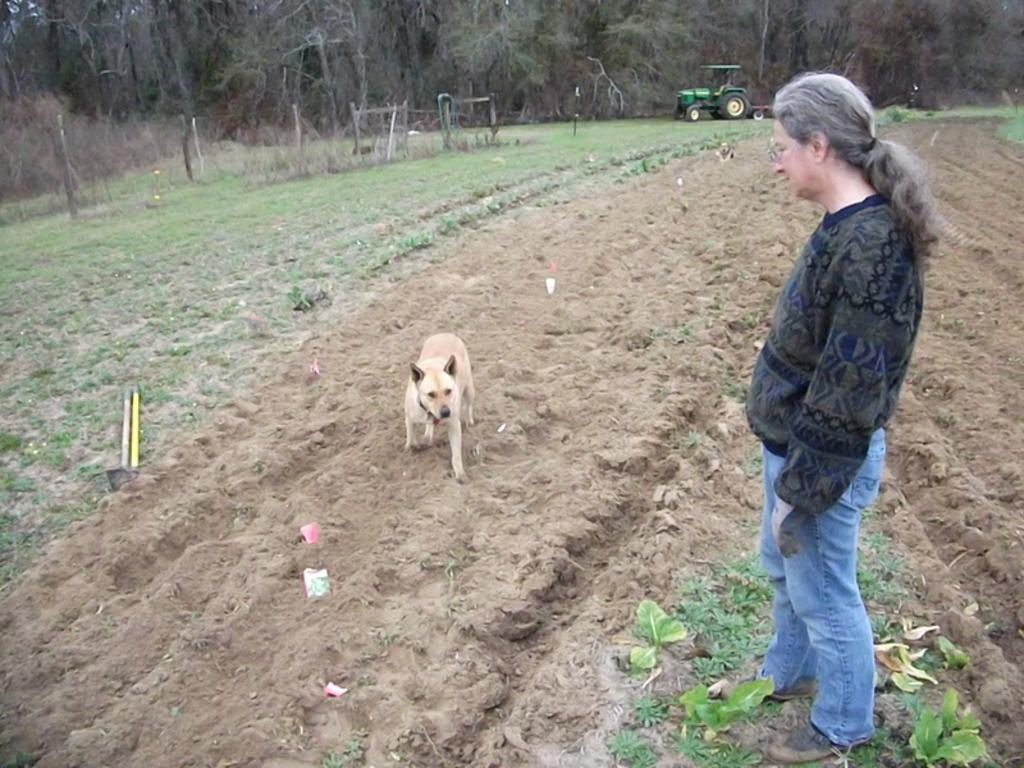What type of vegetation is visible at the top of the image? There are trees at the top of the image. What type of vehicle is present at the top of the image? There is a tractor at the top of the image. Who is on the right side of the image? There is a woman on the right side of the image. What animal is in the middle of the image? There is a dog in the middle of the image. What type of basin is being used by the woman in the image? There is no basin present in the image. What is the woman reading in the image? The image does not show the woman reading anything, nor does it contain any prose. 